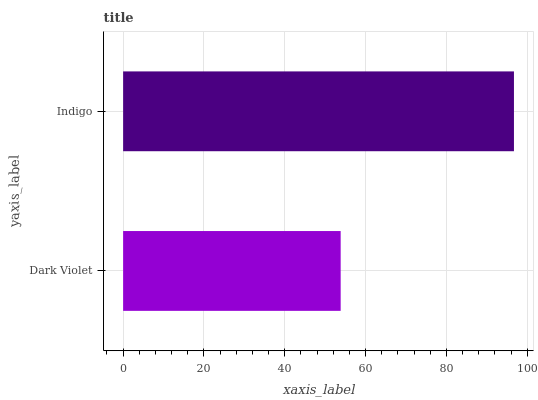Is Dark Violet the minimum?
Answer yes or no. Yes. Is Indigo the maximum?
Answer yes or no. Yes. Is Indigo the minimum?
Answer yes or no. No. Is Indigo greater than Dark Violet?
Answer yes or no. Yes. Is Dark Violet less than Indigo?
Answer yes or no. Yes. Is Dark Violet greater than Indigo?
Answer yes or no. No. Is Indigo less than Dark Violet?
Answer yes or no. No. Is Indigo the high median?
Answer yes or no. Yes. Is Dark Violet the low median?
Answer yes or no. Yes. Is Dark Violet the high median?
Answer yes or no. No. Is Indigo the low median?
Answer yes or no. No. 